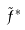<formula> <loc_0><loc_0><loc_500><loc_500>\tilde { f } ^ { * }</formula> 